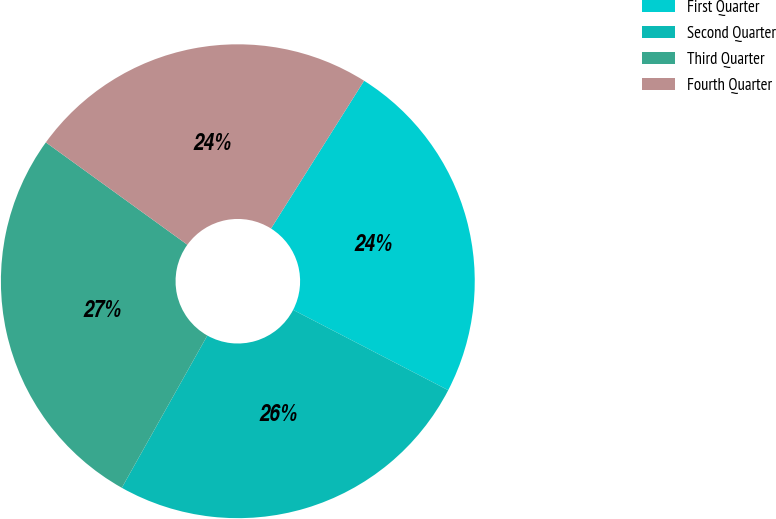Convert chart to OTSL. <chart><loc_0><loc_0><loc_500><loc_500><pie_chart><fcel>First Quarter<fcel>Second Quarter<fcel>Third Quarter<fcel>Fourth Quarter<nl><fcel>23.66%<fcel>25.54%<fcel>26.82%<fcel>23.98%<nl></chart> 